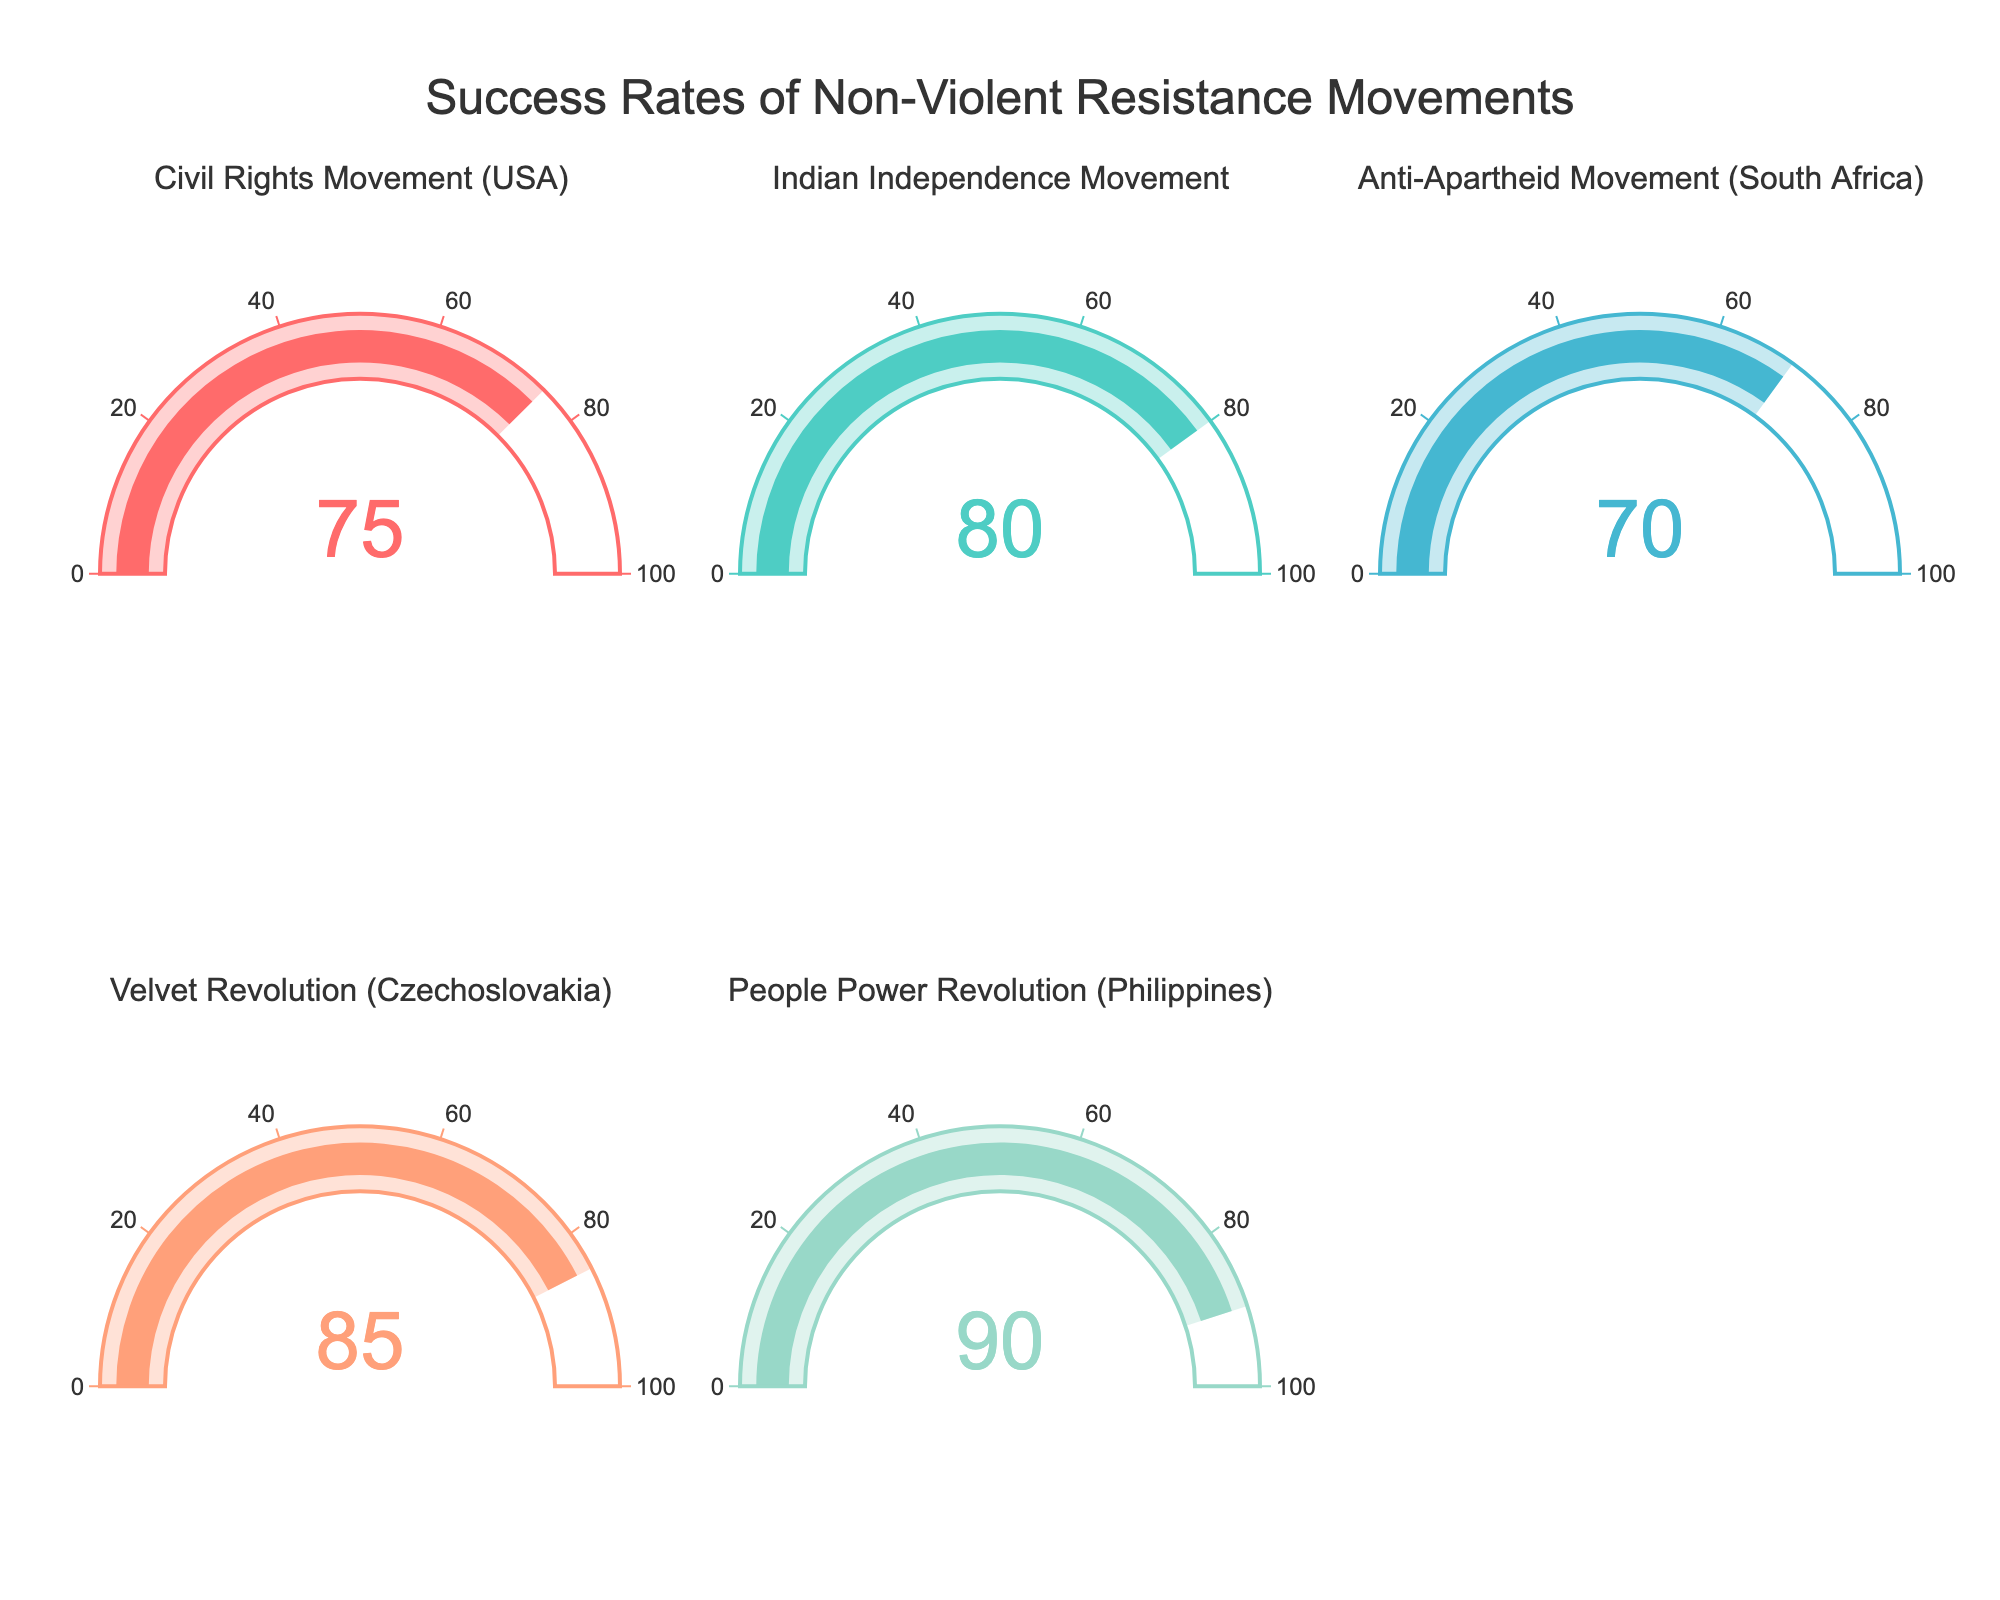What is the highest success rate shown in the figure? The People Power Revolution (Philippines) gauge shows a success rate of 90%, which is the highest among all movements displayed.
Answer: 90% Which movement has the lowest success rate in the figure? The Anti-Apartheid Movement (South Africa) gauge shows a success rate of 70%, which is the lowest among all movements displayed.
Answer: 70% What is the average success rate of all the movements shown in the figure? To find the average, sum all success rates and divide by the number of movements. The sum is 75 + 80 + 70 + 85 + 90 = 400. Dividing by 5, the average is 400 / 5 = 80%.
Answer: 80% Which two movements have success rates closest to each other, and what are their rates? The Indian Independence Movement has a success rate of 80%, and the Civil Rights Movement (USA) has a success rate of 75%. The difference is 80 - 75 = 5, which is the smallest difference among all comparisons.
Answer: Civil Rights Movement (75%) and Indian Independence Movement (80%) How many movements have a success rate of 80% or higher? Movements with success rates of 80% or higher are: Indian Independence Movement (80%), Velvet Revolution (85%), and People Power Revolution (90%), totaling 3 movements.
Answer: 3 What is the difference in success rates between the Velvet Revolution and the Civil Rights Movement? The success rate of the Velvet Revolution is 85%, and that of the Civil Rights Movement is 75%. The difference is 85 - 75 = 10%.
Answer: 10% Is there any movement with a success rate below 75%? There is no movement with a success rate below 75% as the lowest success rate shown is 70%.
Answer: Yes 